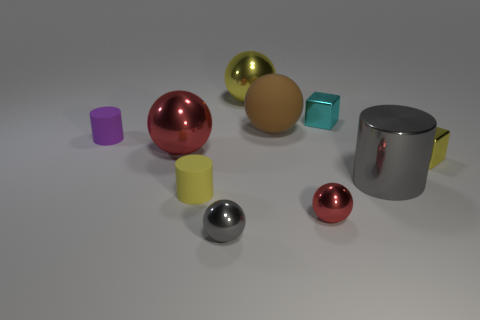Does the rubber ball have the same color as the big object to the left of the small gray shiny ball?
Keep it short and to the point. No. Are there an equal number of brown rubber things that are on the right side of the gray metal cylinder and yellow cylinders left of the tiny red thing?
Make the answer very short. No. How many other things are there of the same size as the brown rubber sphere?
Give a very brief answer. 3. The yellow rubber object is what size?
Provide a succinct answer. Small. Are the small gray ball and the tiny cylinder on the right side of the tiny purple cylinder made of the same material?
Provide a succinct answer. No. Is there another cyan thing of the same shape as the tiny cyan object?
Provide a succinct answer. No. What material is the yellow cylinder that is the same size as the purple matte thing?
Offer a terse response. Rubber. There is a yellow rubber thing that is in front of the cyan cube; what size is it?
Keep it short and to the point. Small. Do the yellow metal object that is in front of the small purple cylinder and the red shiny sphere to the left of the big rubber sphere have the same size?
Keep it short and to the point. No. What number of tiny cyan cubes are made of the same material as the small red thing?
Provide a short and direct response. 1. 